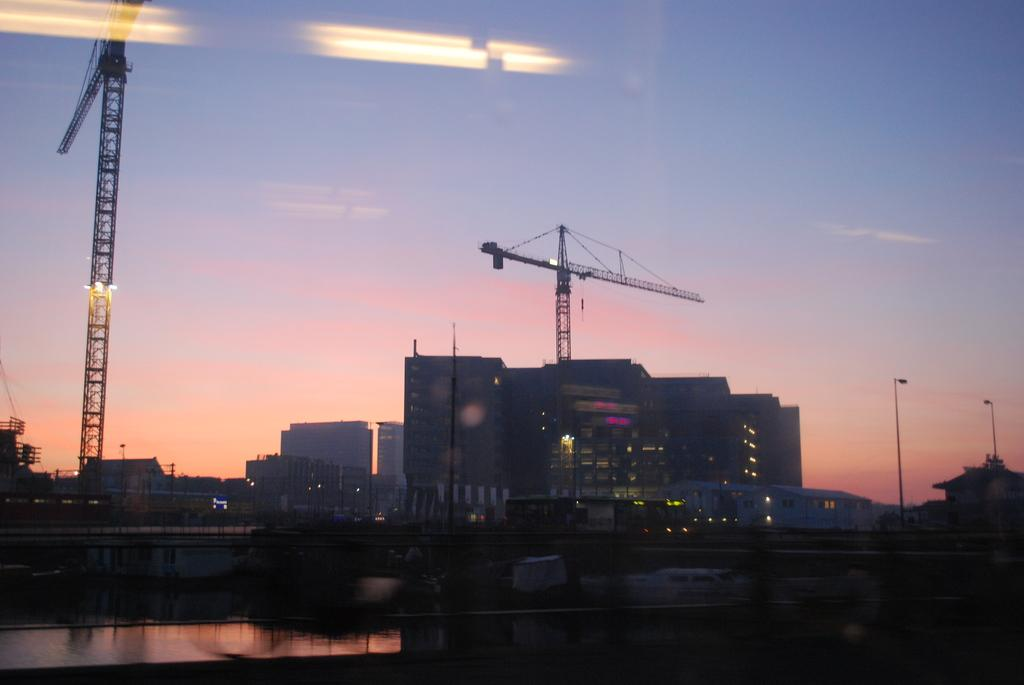What is the main feature of the image? There is a road in the image. What can be seen behind the road? There are buildings behind the road. Are all the buildings completed? No, some of the buildings are under construction. What equipment is present near the buildings? There are cranes near the buildings. What is visible in the background of the image? The sky is visible in the background of the image. What type of insect can be seen controlling the construction process in the image? There are no insects present in the image, and no insects are controlling the construction process. 